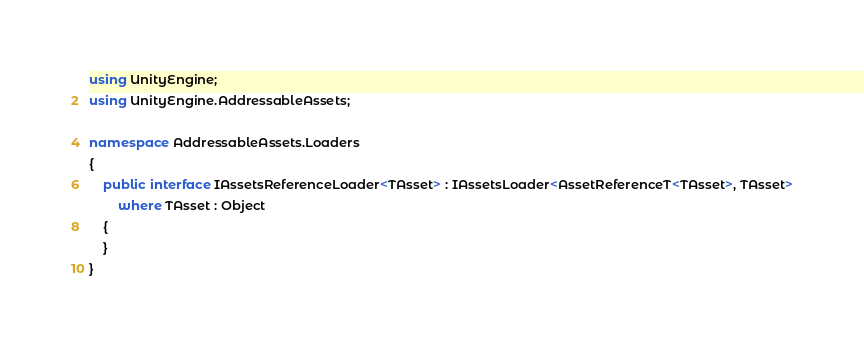Convert code to text. <code><loc_0><loc_0><loc_500><loc_500><_C#_>using UnityEngine;
using UnityEngine.AddressableAssets;

namespace AddressableAssets.Loaders
{
    public interface IAssetsReferenceLoader<TAsset> : IAssetsLoader<AssetReferenceT<TAsset>, TAsset>
        where TAsset : Object
    {
    }
}</code> 